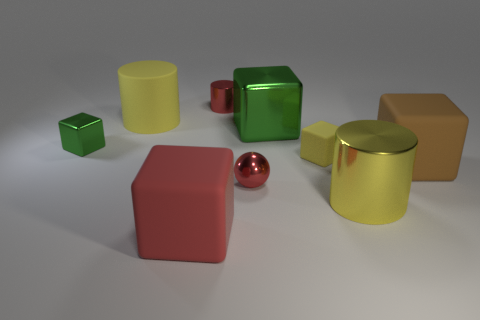Subtract all small red metal cylinders. How many cylinders are left? 2 Subtract all brown cylinders. How many green cubes are left? 2 Subtract all red cylinders. How many cylinders are left? 2 Subtract 4 cubes. How many cubes are left? 1 Add 1 green cubes. How many objects exist? 10 Subtract all cylinders. How many objects are left? 6 Add 1 big brown rubber things. How many big brown rubber things exist? 2 Subtract 0 blue blocks. How many objects are left? 9 Subtract all blue blocks. Subtract all purple cylinders. How many blocks are left? 5 Subtract all small purple shiny cylinders. Subtract all large yellow cylinders. How many objects are left? 7 